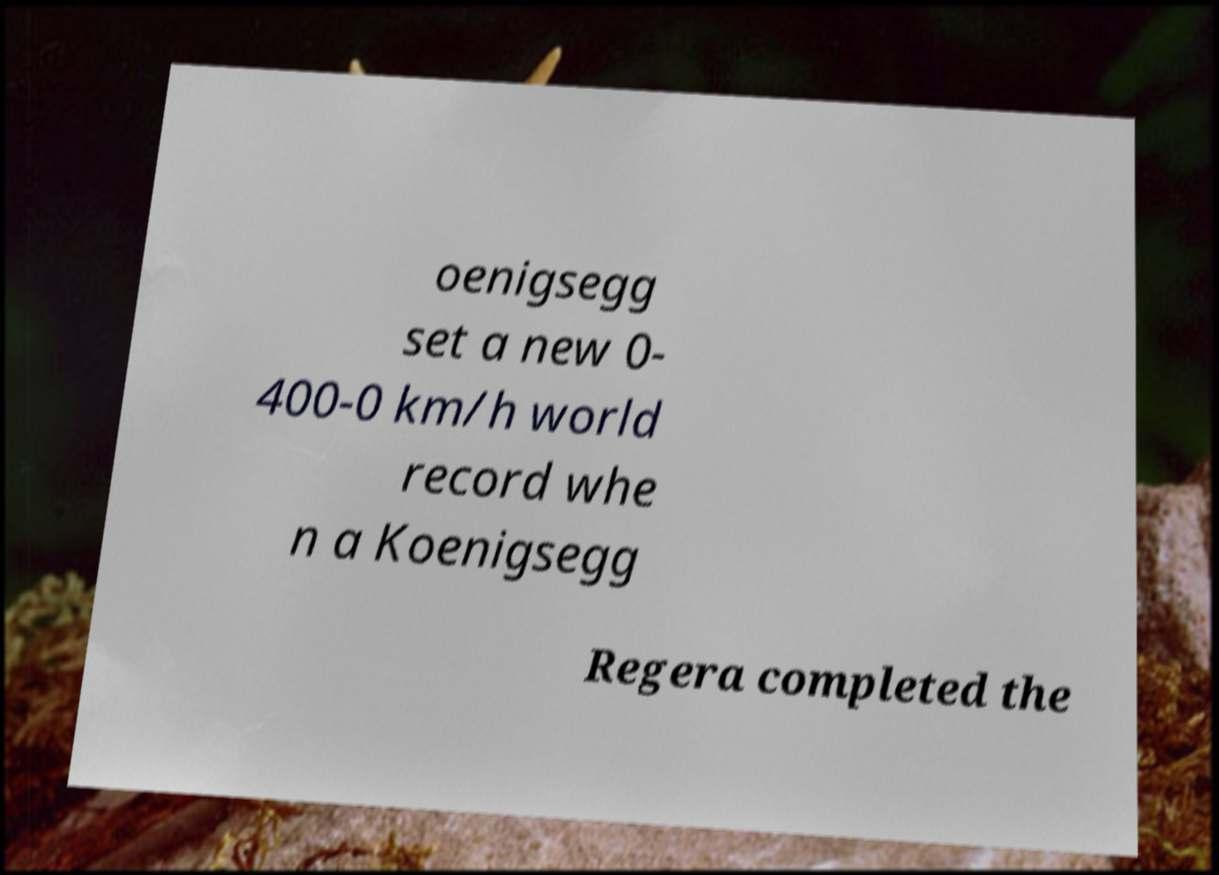Can you accurately transcribe the text from the provided image for me? oenigsegg set a new 0- 400-0 km/h world record whe n a Koenigsegg Regera completed the 